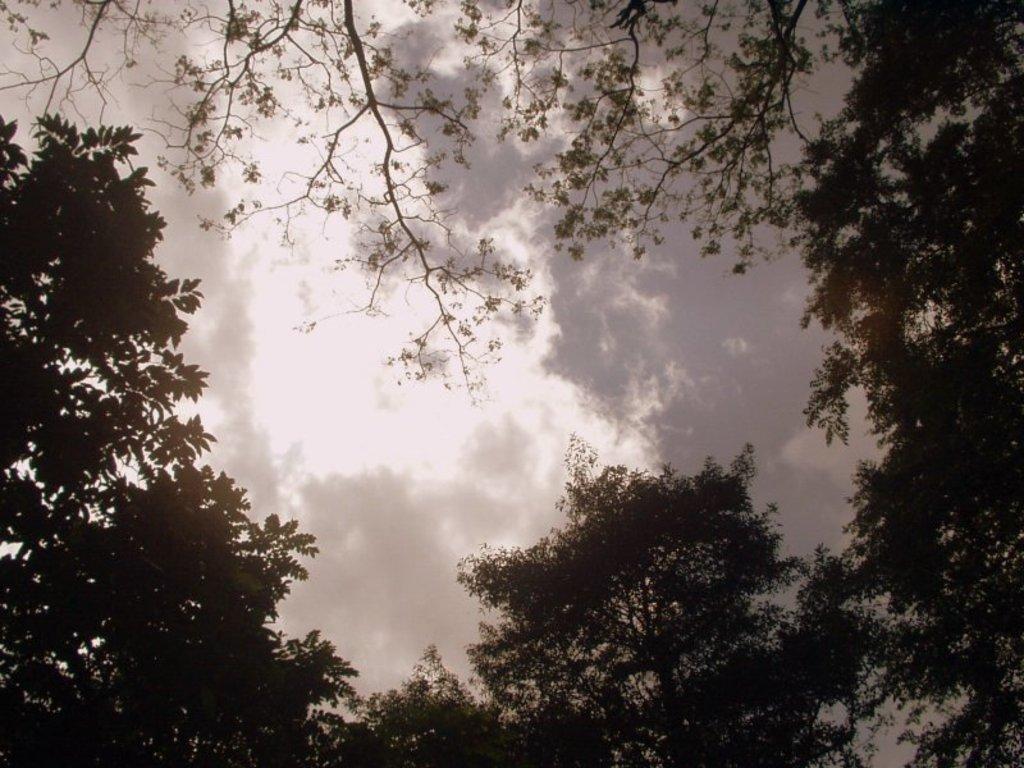Describe this image in one or two sentences. In the picture I can see trees. In the background I can see the sky. 